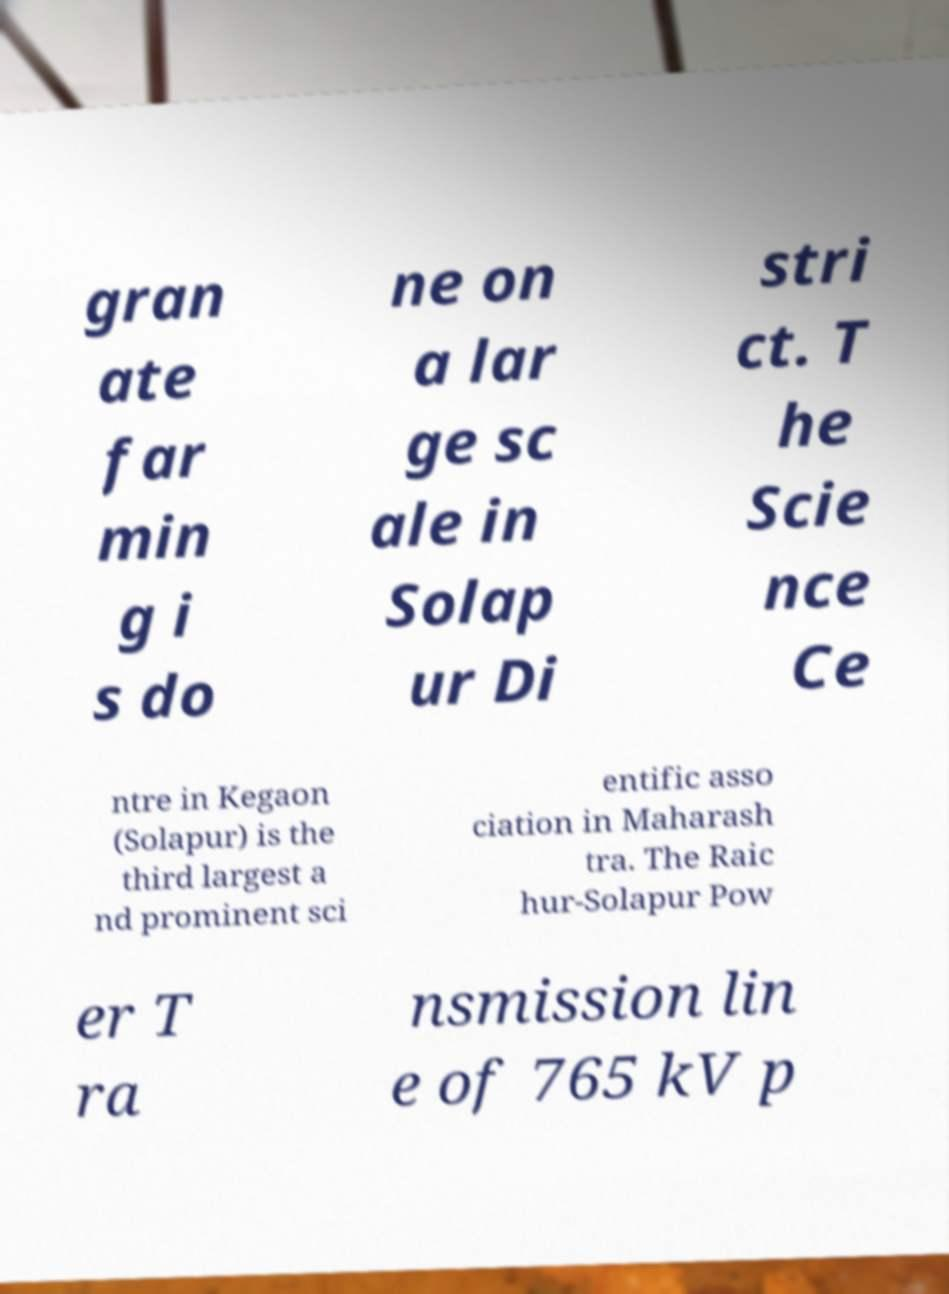Please read and relay the text visible in this image. What does it say? gran ate far min g i s do ne on a lar ge sc ale in Solap ur Di stri ct. T he Scie nce Ce ntre in Kegaon (Solapur) is the third largest a nd prominent sci entific asso ciation in Maharash tra. The Raic hur-Solapur Pow er T ra nsmission lin e of 765 kV p 